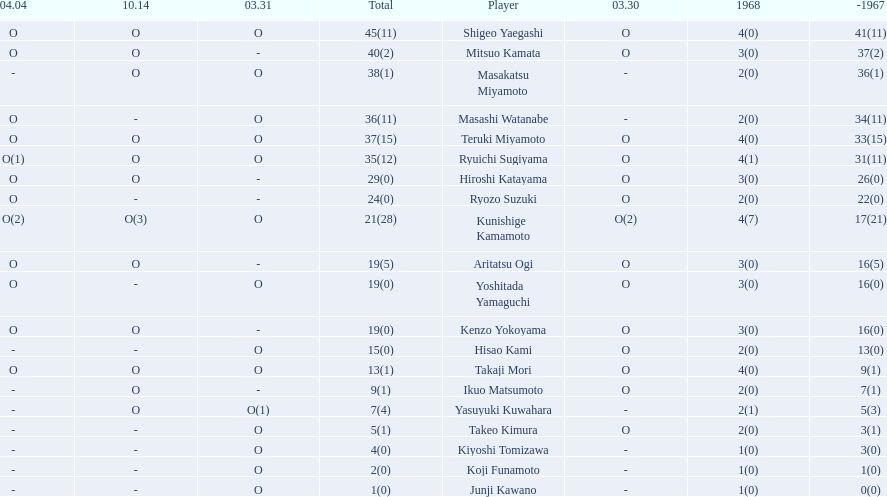Who are all of the players? Shigeo Yaegashi, Mitsuo Kamata, Masakatsu Miyamoto, Masashi Watanabe, Teruki Miyamoto, Ryuichi Sugiyama, Hiroshi Katayama, Ryozo Suzuki, Kunishige Kamamoto, Aritatsu Ogi, Yoshitada Yamaguchi, Kenzo Yokoyama, Hisao Kami, Takaji Mori, Ikuo Matsumoto, Yasuyuki Kuwahara, Takeo Kimura, Kiyoshi Tomizawa, Koji Funamoto, Junji Kawano. How many points did they receive? 45(11), 40(2), 38(1), 36(11), 37(15), 35(12), 29(0), 24(0), 21(28), 19(5), 19(0), 19(0), 15(0), 13(1), 9(1), 7(4), 5(1), 4(0), 2(0), 1(0). What about just takaji mori and junji kawano? 13(1), 1(0). Of the two, who had more points? Takaji Mori. Can you give me this table as a dict? {'header': ['04.04', '10.14', '03.31', 'Total', 'Player', '03.30', '1968', '-1967'], 'rows': [['O', 'O', 'O', '45(11)', 'Shigeo Yaegashi', 'O', '4(0)', '41(11)'], ['O', 'O', '-', '40(2)', 'Mitsuo Kamata', 'O', '3(0)', '37(2)'], ['-', 'O', 'O', '38(1)', 'Masakatsu Miyamoto', '-', '2(0)', '36(1)'], ['O', '-', 'O', '36(11)', 'Masashi Watanabe', '-', '2(0)', '34(11)'], ['O', 'O', 'O', '37(15)', 'Teruki Miyamoto', 'O', '4(0)', '33(15)'], ['O(1)', 'O', 'O', '35(12)', 'Ryuichi Sugiyama', 'O', '4(1)', '31(11)'], ['O', 'O', '-', '29(0)', 'Hiroshi Katayama', 'O', '3(0)', '26(0)'], ['O', '-', '-', '24(0)', 'Ryozo Suzuki', 'O', '2(0)', '22(0)'], ['O(2)', 'O(3)', 'O', '21(28)', 'Kunishige Kamamoto', 'O(2)', '4(7)', '17(21)'], ['O', 'O', '-', '19(5)', 'Aritatsu Ogi', 'O', '3(0)', '16(5)'], ['O', '-', 'O', '19(0)', 'Yoshitada Yamaguchi', 'O', '3(0)', '16(0)'], ['O', 'O', '-', '19(0)', 'Kenzo Yokoyama', 'O', '3(0)', '16(0)'], ['-', '-', 'O', '15(0)', 'Hisao Kami', 'O', '2(0)', '13(0)'], ['O', 'O', 'O', '13(1)', 'Takaji Mori', 'O', '4(0)', '9(1)'], ['-', 'O', '-', '9(1)', 'Ikuo Matsumoto', 'O', '2(0)', '7(1)'], ['-', 'O', 'O(1)', '7(4)', 'Yasuyuki Kuwahara', '-', '2(1)', '5(3)'], ['-', '-', 'O', '5(1)', 'Takeo Kimura', 'O', '2(0)', '3(1)'], ['-', '-', 'O', '4(0)', 'Kiyoshi Tomizawa', '-', '1(0)', '3(0)'], ['-', '-', 'O', '2(0)', 'Koji Funamoto', '-', '1(0)', '1(0)'], ['-', '-', 'O', '1(0)', 'Junji Kawano', '-', '1(0)', '0(0)']]} 